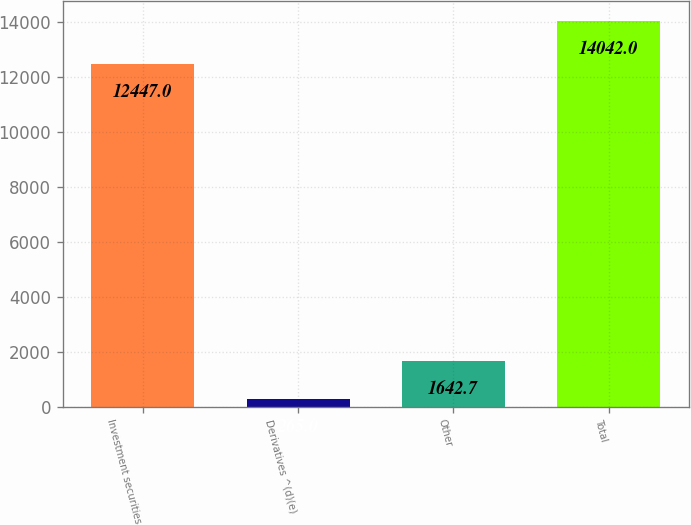Convert chart to OTSL. <chart><loc_0><loc_0><loc_500><loc_500><bar_chart><fcel>Investment securities<fcel>Derivatives ^(d)(e)<fcel>Other<fcel>Total<nl><fcel>12447<fcel>265<fcel>1642.7<fcel>14042<nl></chart> 